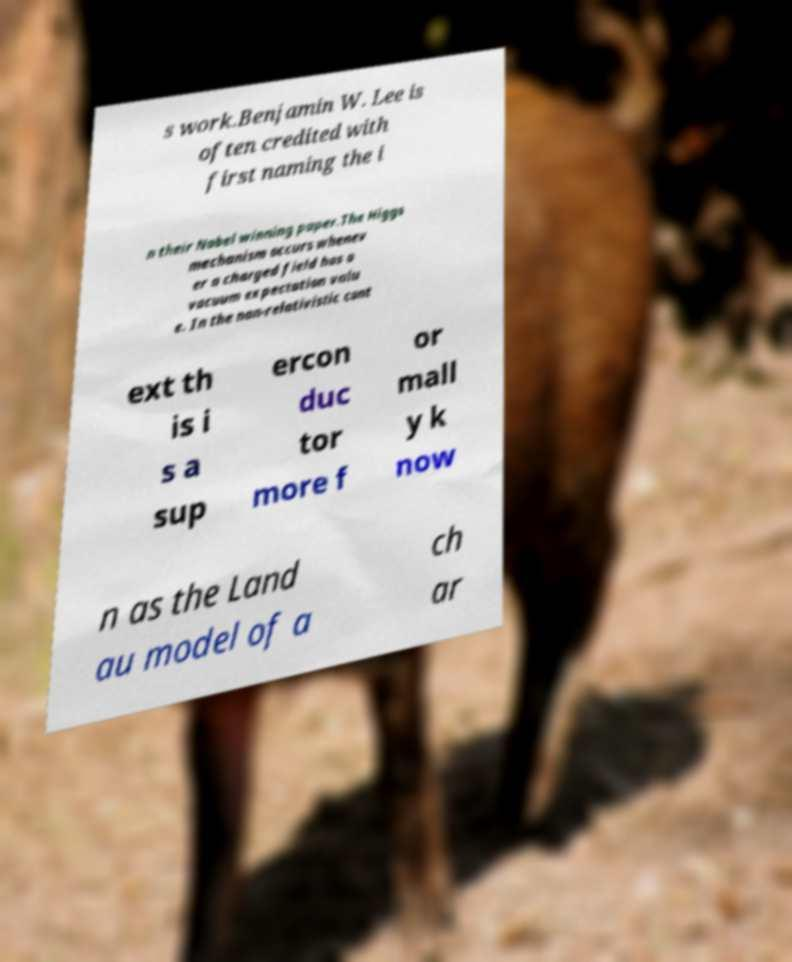What messages or text are displayed in this image? I need them in a readable, typed format. s work.Benjamin W. Lee is often credited with first naming the i n their Nobel winning paper.The Higgs mechanism occurs whenev er a charged field has a vacuum expectation valu e. In the non-relativistic cont ext th is i s a sup ercon duc tor more f or mall y k now n as the Land au model of a ch ar 